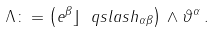Convert formula to latex. <formula><loc_0><loc_0><loc_500><loc_500>\Lambda \colon = \left ( e ^ { \beta } \rfloor \ q s l a s h _ { \alpha \beta } \right ) \, \wedge \vartheta ^ { \alpha } \, .</formula> 